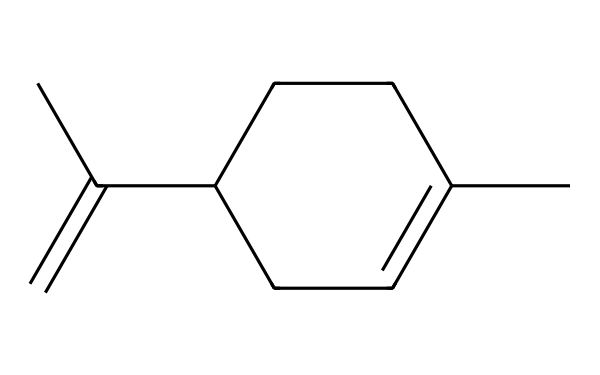What is the molecular formula of limonene? To determine the molecular formula, count the number of each type of atom in the structure. The SMILES notation shows 10 carbon atoms (C) and 16 hydrogen atoms (H) in total. Thus, the molecular formula is derived from the counts.
Answer: C10H16 How many rings are present in limonene's structure? Analyzing the structure, it shows a cyclohexene ring present in the SMILES. A cyclohexene ring contains 6 carbon atoms arranged in a loop, indicating there is one ring.
Answer: 1 What type of chemical compound is limonene? The structure includes a ring and double bonds, specifically a cyclic monoterpene as indicated by the presence of a cyclic alkene and its formula.
Answer: monoterpene What is the number of double bonds in limonene? The structure indicates the presence of one double bond in addition to the double bond within the ring structure. Counting these gives a total of two double bonds in different parts of the molecule.
Answer: 2 Is limonene a saturated or unsaturated compound? Based on the presence of double bonds in its structure, limonene cannot be fully saturated with hydrogen atoms. Thus, it is classified as an unsaturated compound due to those double bonds.
Answer: unsaturated Which part of the limonene structure contributes to its citrus aroma? The specific configuration of the double bond and the ring structure is crucial for the aromatic compounds, giving limonene its characteristic citrus scent, derived from the cyclic structure which is typical for aromatic compounds.
Answer: cyclic structure 